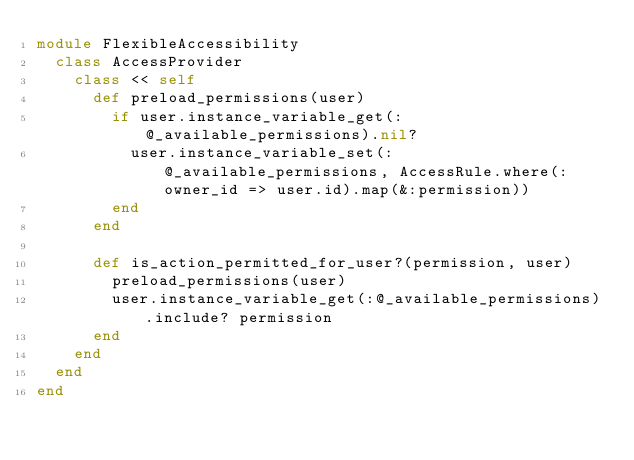Convert code to text. <code><loc_0><loc_0><loc_500><loc_500><_Ruby_>module FlexibleAccessibility
  class AccessProvider
    class << self
      def preload_permissions(user)
        if user.instance_variable_get(:@_available_permissions).nil?
          user.instance_variable_set(:@_available_permissions, AccessRule.where(:owner_id => user.id).map(&:permission))
        end
      end

      def is_action_permitted_for_user?(permission, user)
        preload_permissions(user)
        user.instance_variable_get(:@_available_permissions).include? permission
      end
    end
  end
end
</code> 